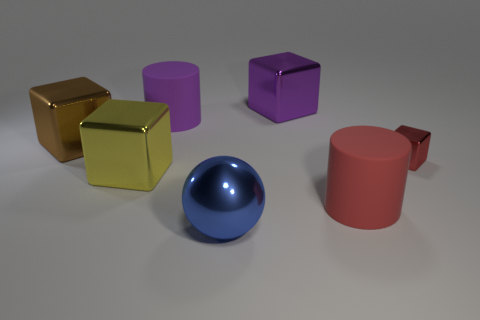Add 1 tiny green metal balls. How many objects exist? 8 Subtract all cylinders. How many objects are left? 5 Subtract all big yellow cubes. Subtract all tiny metal things. How many objects are left? 5 Add 1 yellow cubes. How many yellow cubes are left? 2 Add 3 cyan rubber cubes. How many cyan rubber cubes exist? 3 Subtract 1 red blocks. How many objects are left? 6 